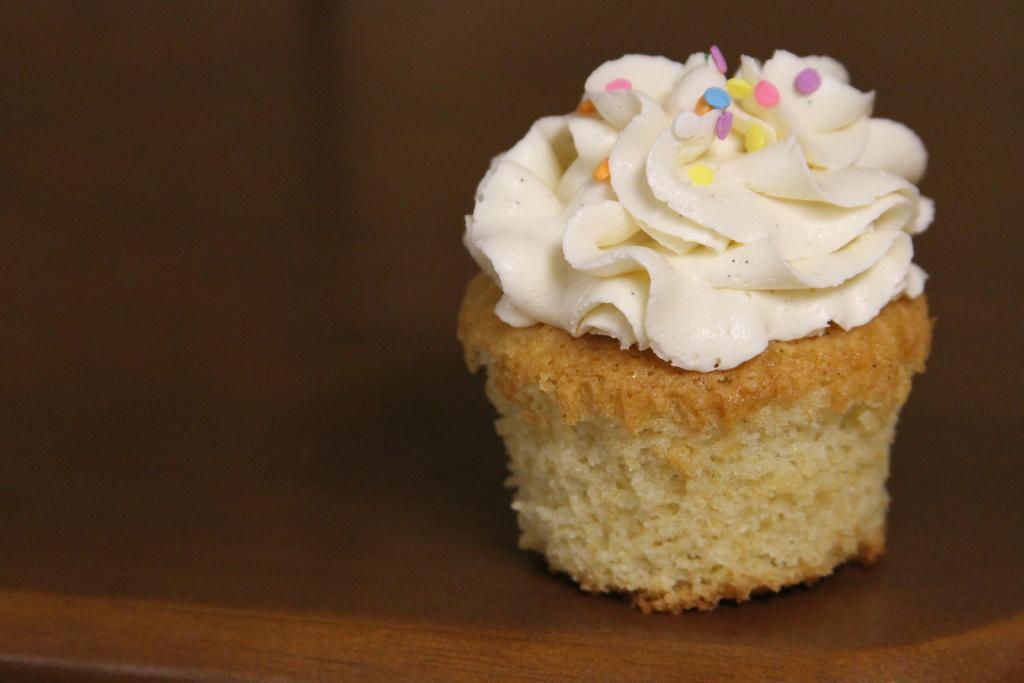Could you give a brief overview of what you see in this image? In this image there is a cupcake on the table. On the cupcake there is some cream and few candies. 